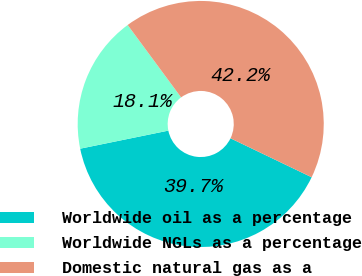Convert chart to OTSL. <chart><loc_0><loc_0><loc_500><loc_500><pie_chart><fcel>Worldwide oil as a percentage<fcel>Worldwide NGLs as a percentage<fcel>Domestic natural gas as a<nl><fcel>39.66%<fcel>18.1%<fcel>42.24%<nl></chart> 